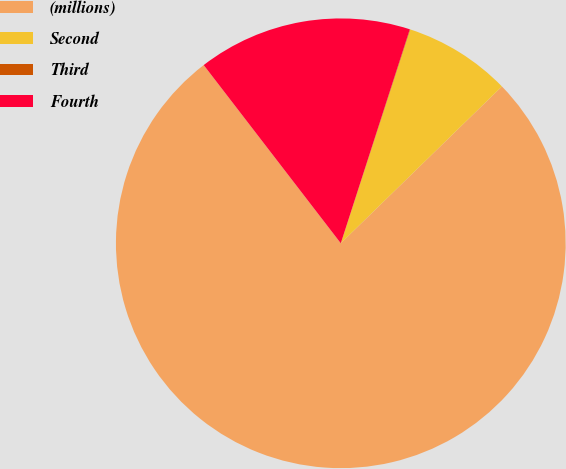Convert chart. <chart><loc_0><loc_0><loc_500><loc_500><pie_chart><fcel>(millions)<fcel>Second<fcel>Third<fcel>Fourth<nl><fcel>76.85%<fcel>7.72%<fcel>0.03%<fcel>15.4%<nl></chart> 